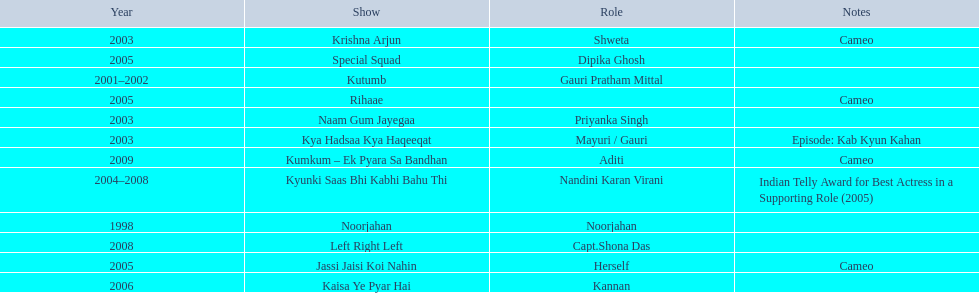What role  was played for the latest show Cameo. Who played the last cameo before ? Jassi Jaisi Koi Nahin. 